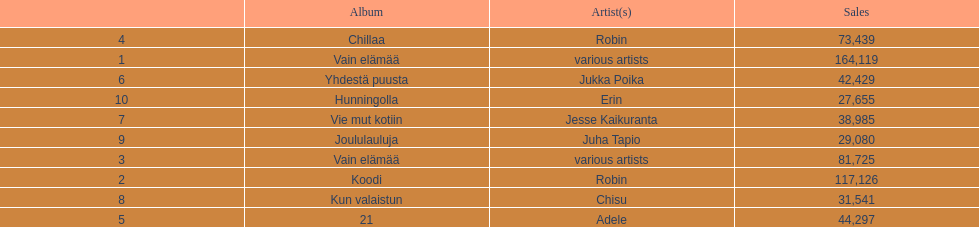How many albums sold for than 50,000 copies this year? 4. 